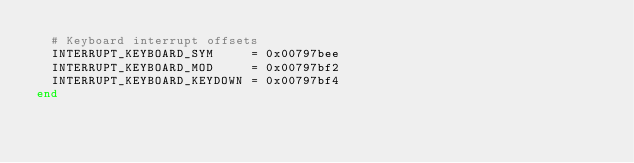Convert code to text. <code><loc_0><loc_0><loc_500><loc_500><_Crystal_>  # Keyboard interrupt offsets
  INTERRUPT_KEYBOARD_SYM     = 0x00797bee
  INTERRUPT_KEYBOARD_MOD     = 0x00797bf2
  INTERRUPT_KEYBOARD_KEYDOWN = 0x00797bf4
end
</code> 